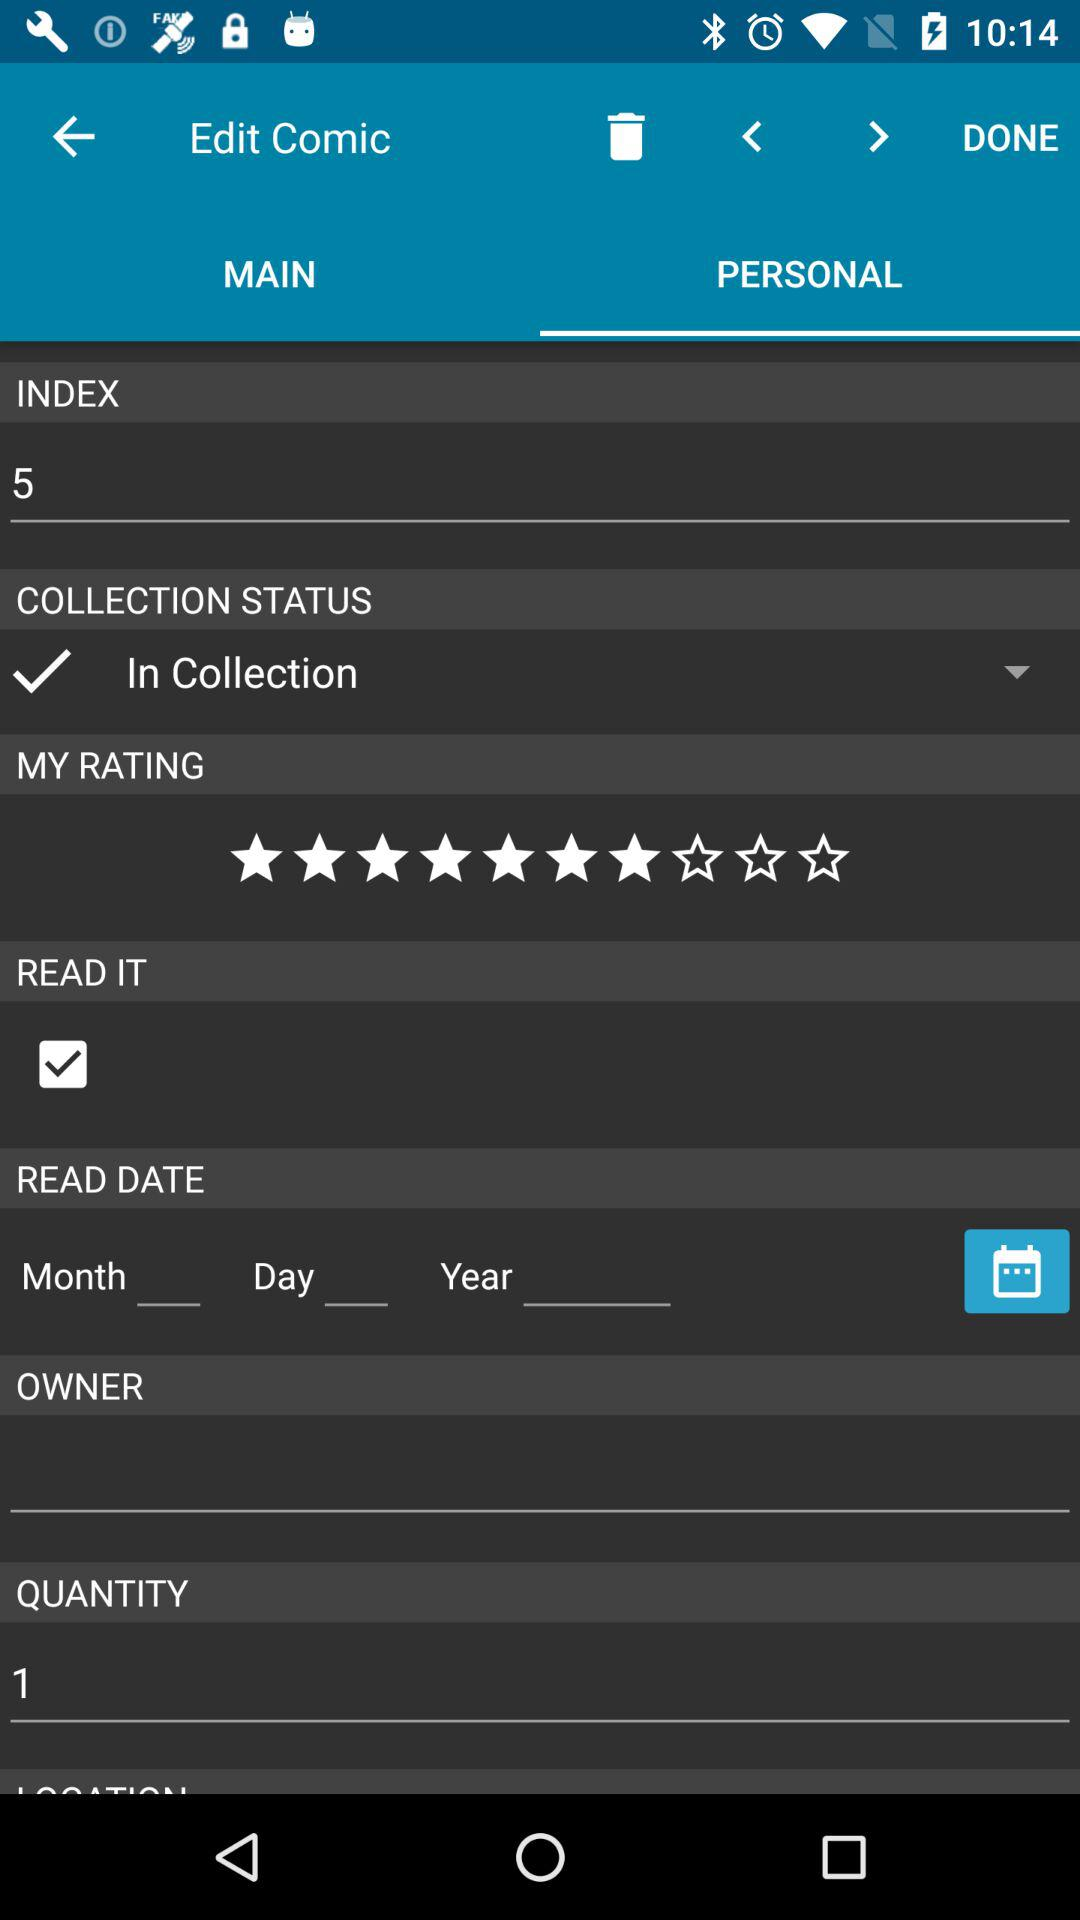How many stars are given to the comic? There are 7 stars given to the comic. 